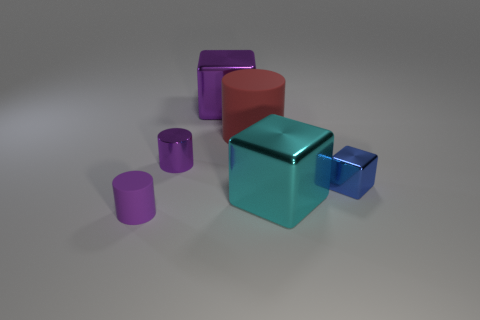How does the lighting in the image affect the appearance of the objects? The lighting in the image creates an ambient effect, with soft shadows that contribute to the sense of depth, and highlights on the objects that enhance their metallic and shiny finishes.  Can you describe the shape of the largest object in the image? The largest object in the image is a rectangular prism with a glossy purple finish, which gives it a sleek and smooth look, reflecting the environment around it. 